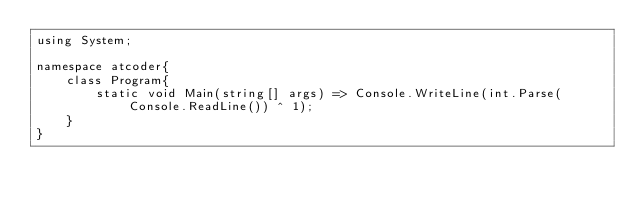<code> <loc_0><loc_0><loc_500><loc_500><_C#_>using System;

namespace atcoder{
    class Program{
        static void Main(string[] args) => Console.WriteLine(int.Parse(Console.ReadLine()) ^ 1);
    }
}
</code> 